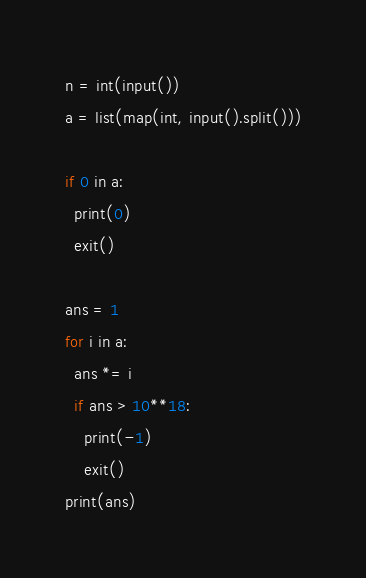<code> <loc_0><loc_0><loc_500><loc_500><_Python_>n = int(input())
a = list(map(int, input().split()))

if 0 in a:
  print(0)
  exit()

ans = 1
for i in a:
  ans *= i
  if ans > 10**18:
    print(-1)
    exit()
print(ans)</code> 